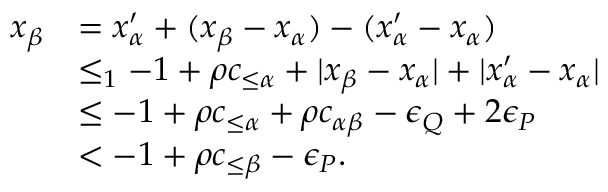Convert formula to latex. <formula><loc_0><loc_0><loc_500><loc_500>\begin{array} { r l } { x _ { \beta } } & { = x _ { \alpha } ^ { \prime } + ( x _ { \beta } - x _ { \alpha } ) - ( x _ { \alpha } ^ { \prime } - x _ { \alpha } ) } \\ & { \leq _ { 1 } - 1 + \rho c _ { \leq \alpha } + | x _ { \beta } - x _ { \alpha } | + | x _ { \alpha } ^ { \prime } - x _ { \alpha } | } \\ & { \leq - 1 + \rho c _ { \leq \alpha } + \rho c _ { \alpha \beta } - \epsilon _ { Q } + 2 \epsilon _ { P } } \\ & { < - 1 + \rho c _ { \leq \beta } - \epsilon _ { P } . } \end{array}</formula> 